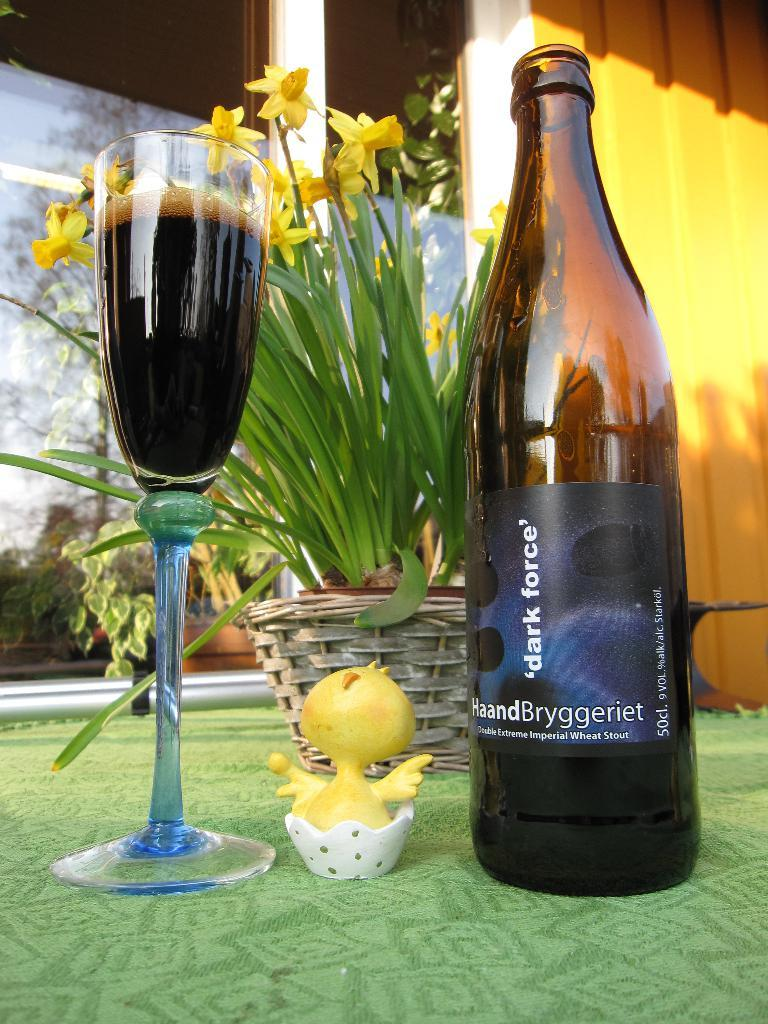What type of container is visible in the image? There is a glass in the image. What other object can be seen in the image? There is a bottle in the image. What non-edible item is present in the image? There is a toy in the image. What type of plant is in the image? There is a plant in the image. What type of flowers are in the image? There are flowers in the image. What surface is visible in the image? There is a floor in the image. What type of celery is being used as a notebook in the image? There is no celery or notebook present in the image. What color is the gold in the image? There is no gold present in the image. 